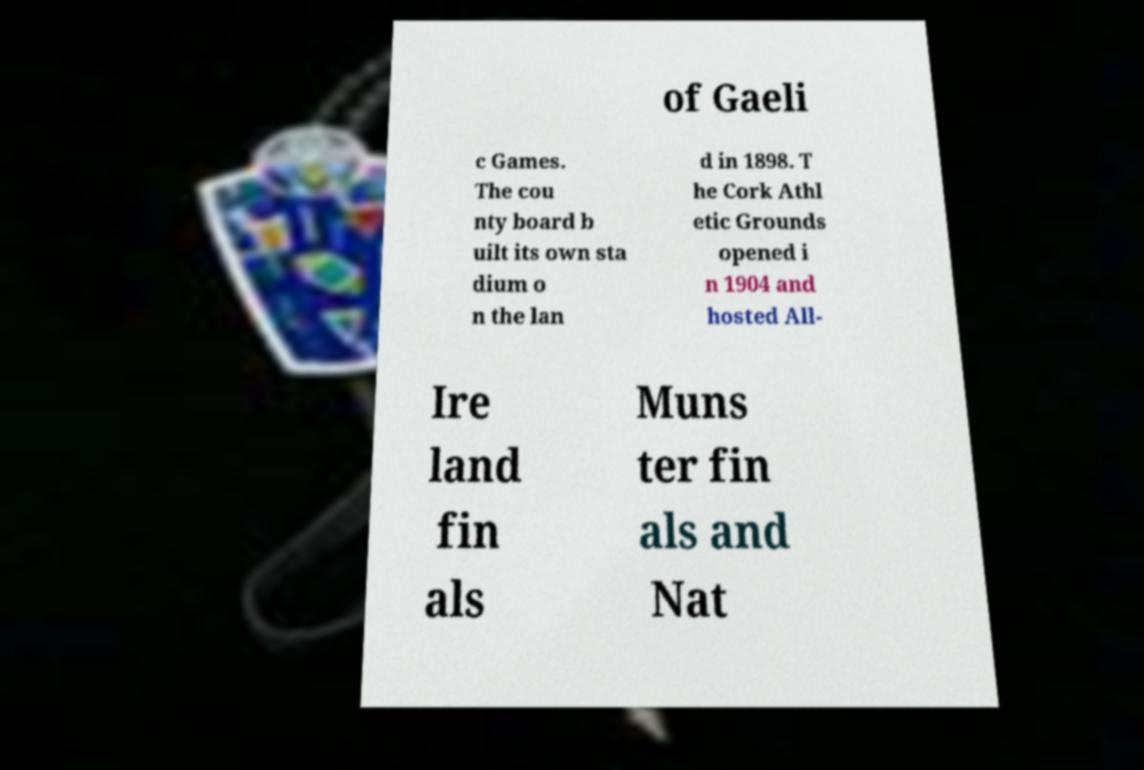Can you accurately transcribe the text from the provided image for me? of Gaeli c Games. The cou nty board b uilt its own sta dium o n the lan d in 1898. T he Cork Athl etic Grounds opened i n 1904 and hosted All- Ire land fin als Muns ter fin als and Nat 